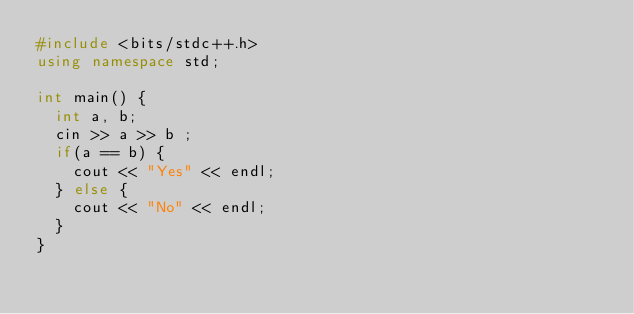<code> <loc_0><loc_0><loc_500><loc_500><_C++_>#include <bits/stdc++.h>
using namespace std;
 
int main() {
  int a, b;
  cin >> a >> b ;
  if(a == b) {
    cout << "Yes" << endl;
  } else {
    cout << "No" << endl;
  }
}</code> 